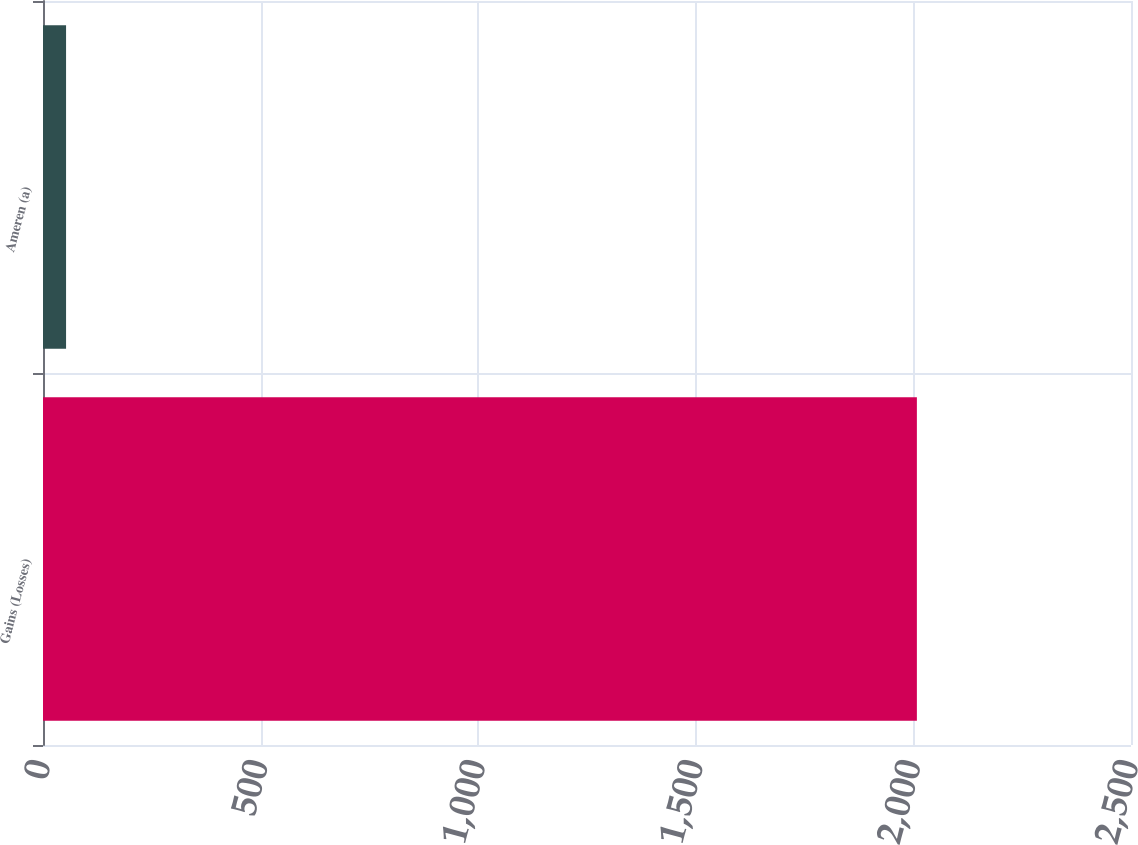Convert chart. <chart><loc_0><loc_0><loc_500><loc_500><bar_chart><fcel>Gains (Losses)<fcel>Ameren (a)<nl><fcel>2008<fcel>53<nl></chart> 